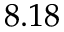<formula> <loc_0><loc_0><loc_500><loc_500>8 . 1 8</formula> 